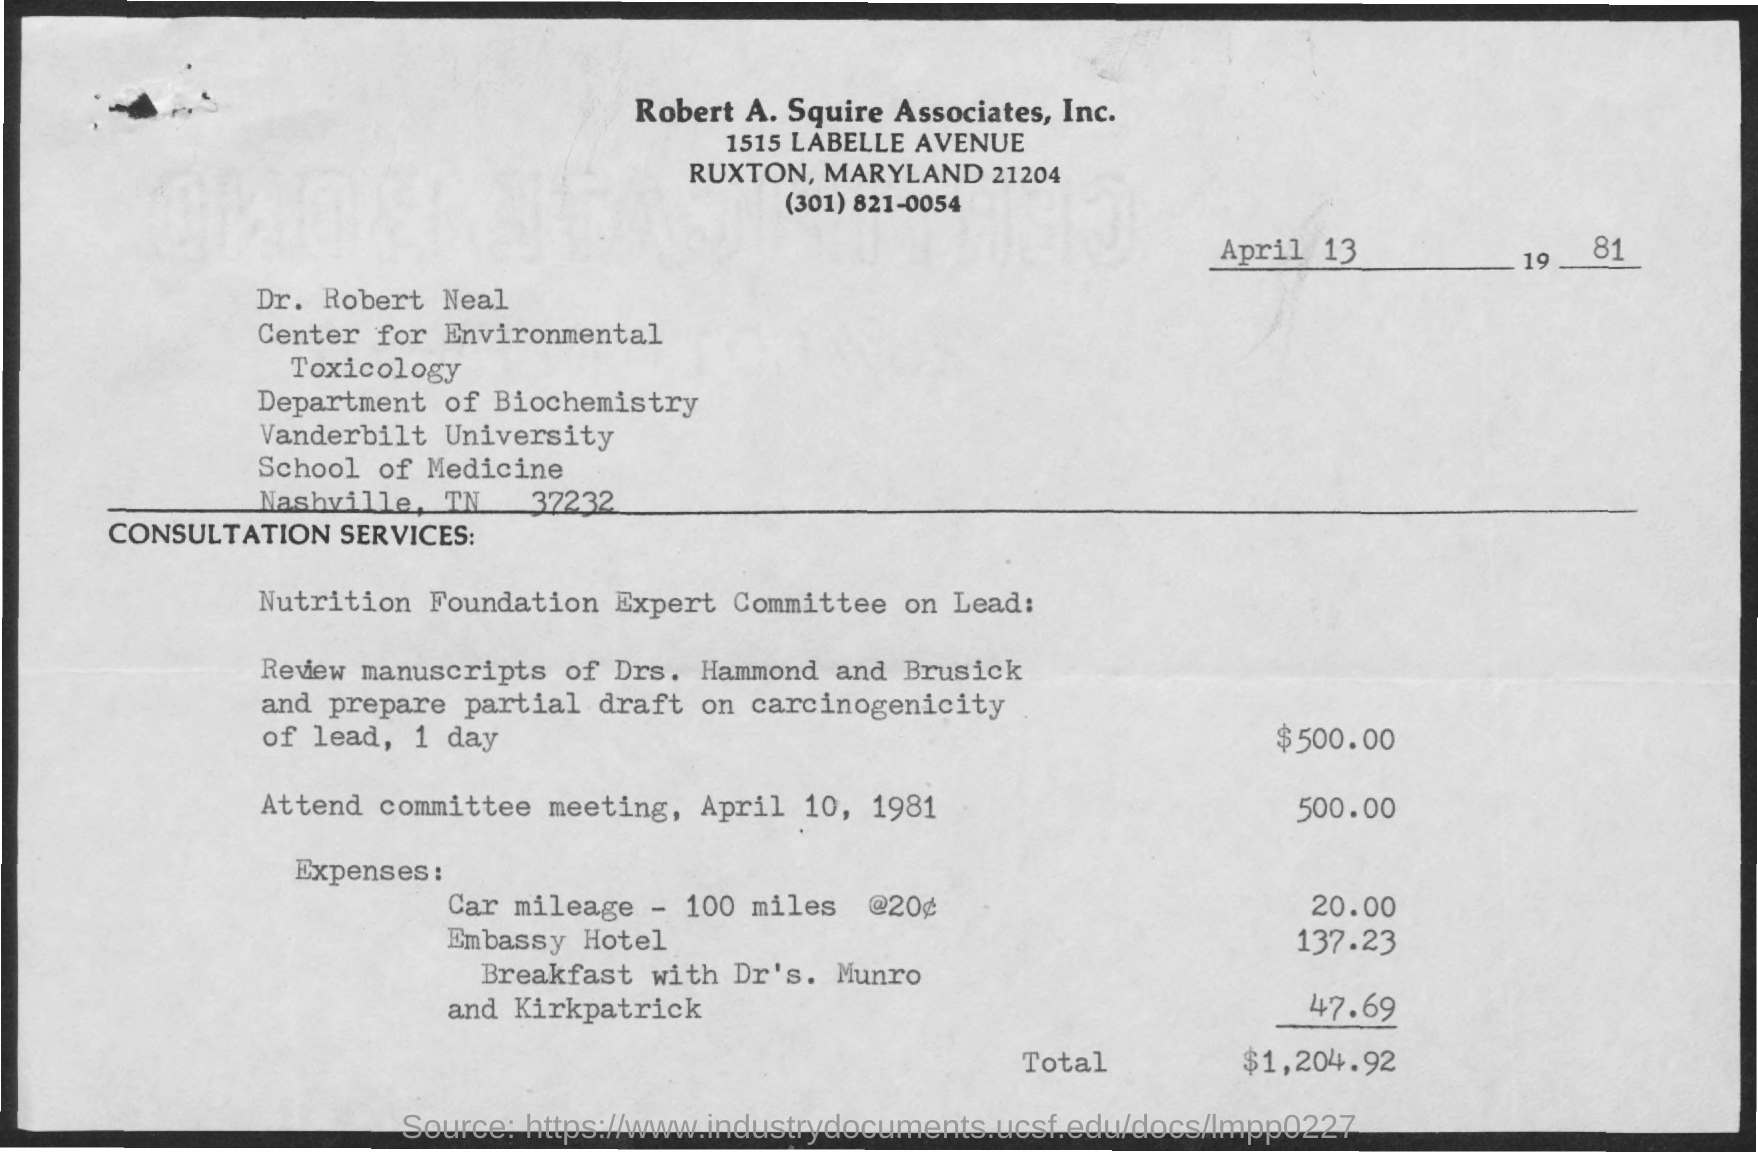What is the date mentioned in the given page ?
Provide a succinct answer. April 13, 1981. To which department dr. robert neal belongs to ?
Provide a succinct answer. Department of biochemistry. To which university dr. robert neal belongs to ?
Ensure brevity in your answer.  Vanderbilt university. What is the amount of expenses for car mileage ?
Your response must be concise. 20. What is the amount of expenses mentioned for embassy hotel ?
Your answer should be compact. 137.23. What is the amount of expenses mentioned for breakfast ?
Keep it short and to the point. 47.69. What is the total amount mentioned ?
Offer a very short reply. 1,204.92. 